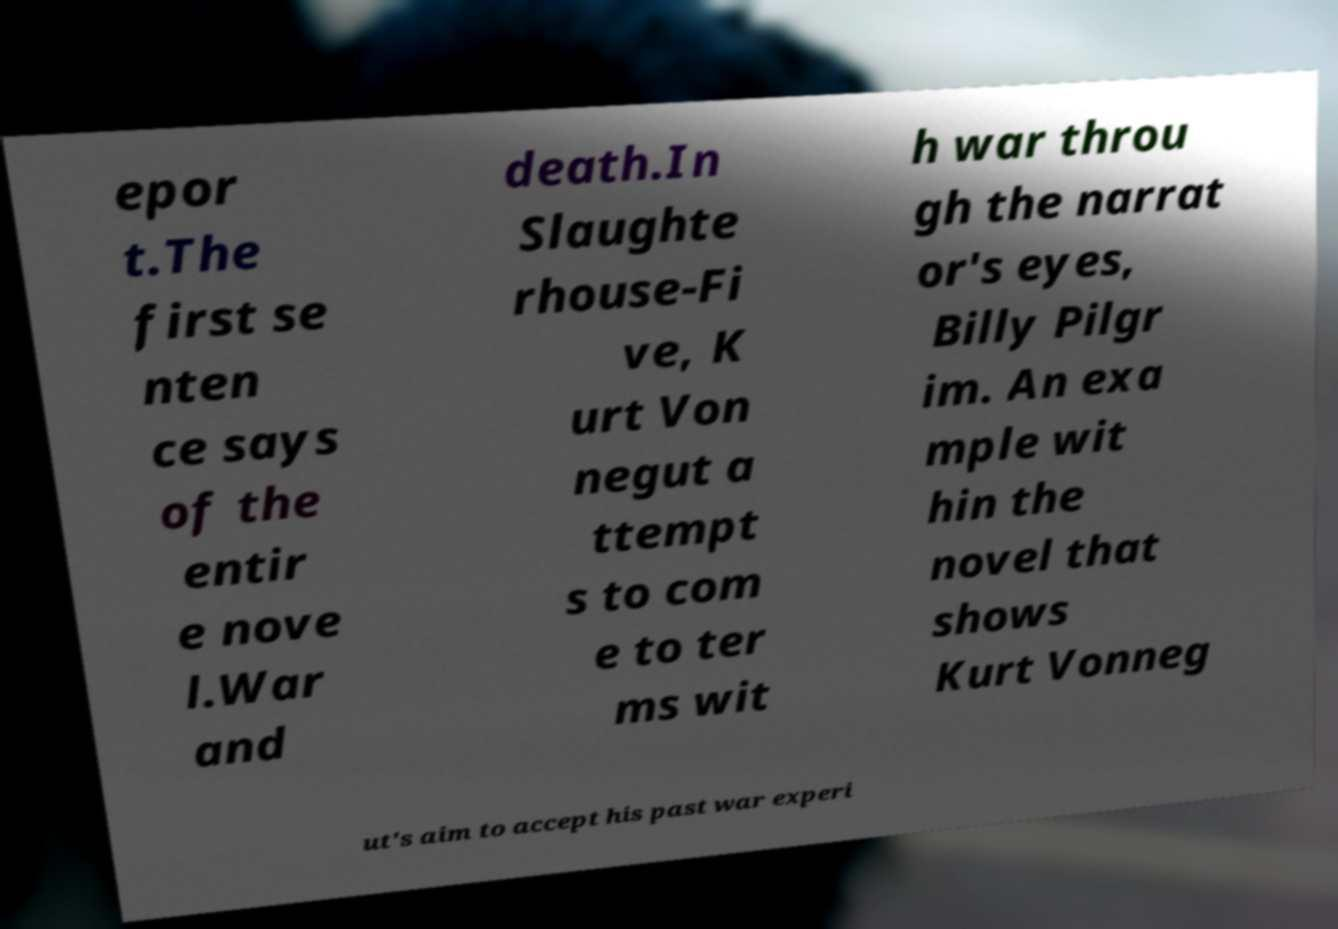For documentation purposes, I need the text within this image transcribed. Could you provide that? epor t.The first se nten ce says of the entir e nove l.War and death.In Slaughte rhouse-Fi ve, K urt Von negut a ttempt s to com e to ter ms wit h war throu gh the narrat or's eyes, Billy Pilgr im. An exa mple wit hin the novel that shows Kurt Vonneg ut's aim to accept his past war experi 